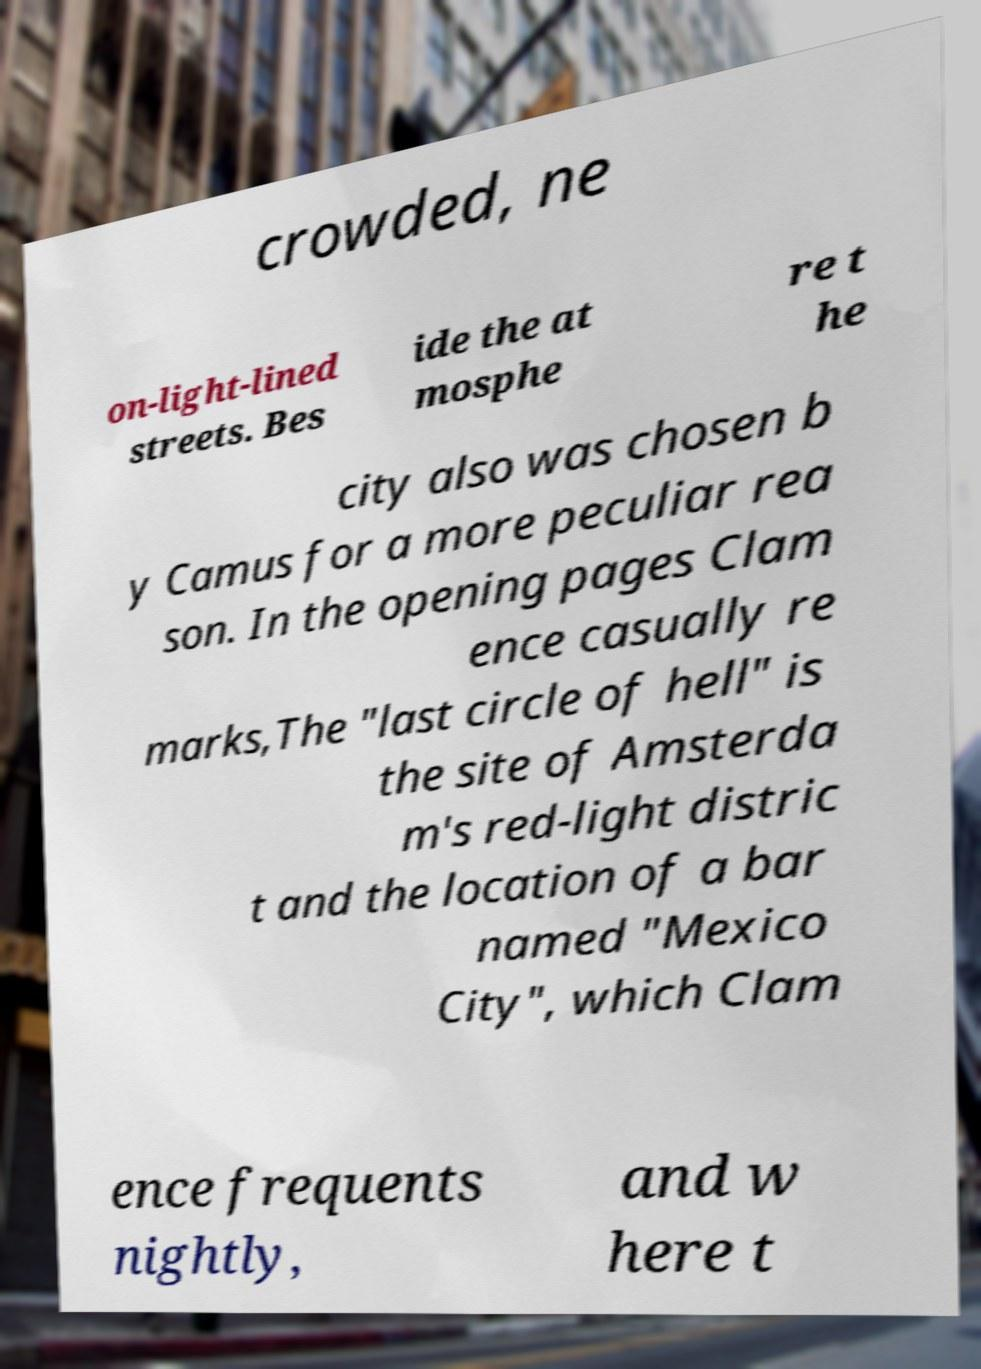For documentation purposes, I need the text within this image transcribed. Could you provide that? crowded, ne on-light-lined streets. Bes ide the at mosphe re t he city also was chosen b y Camus for a more peculiar rea son. In the opening pages Clam ence casually re marks,The "last circle of hell" is the site of Amsterda m's red-light distric t and the location of a bar named "Mexico City", which Clam ence frequents nightly, and w here t 